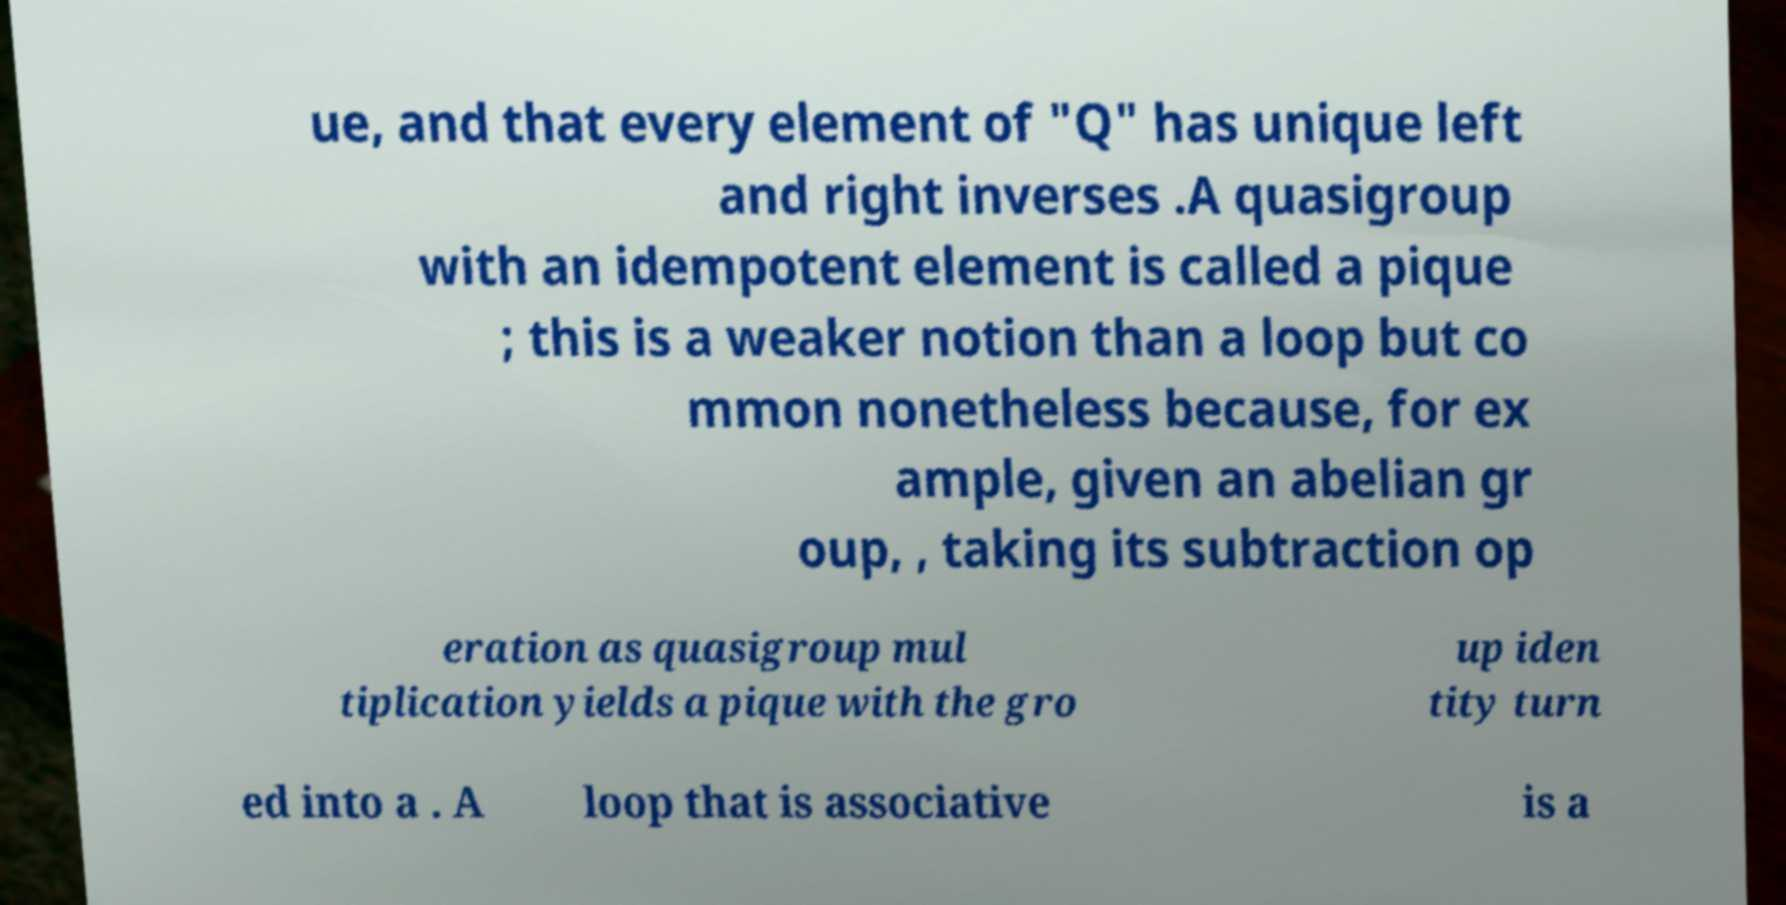There's text embedded in this image that I need extracted. Can you transcribe it verbatim? ue, and that every element of "Q" has unique left and right inverses .A quasigroup with an idempotent element is called a pique ; this is a weaker notion than a loop but co mmon nonetheless because, for ex ample, given an abelian gr oup, , taking its subtraction op eration as quasigroup mul tiplication yields a pique with the gro up iden tity turn ed into a . A loop that is associative is a 